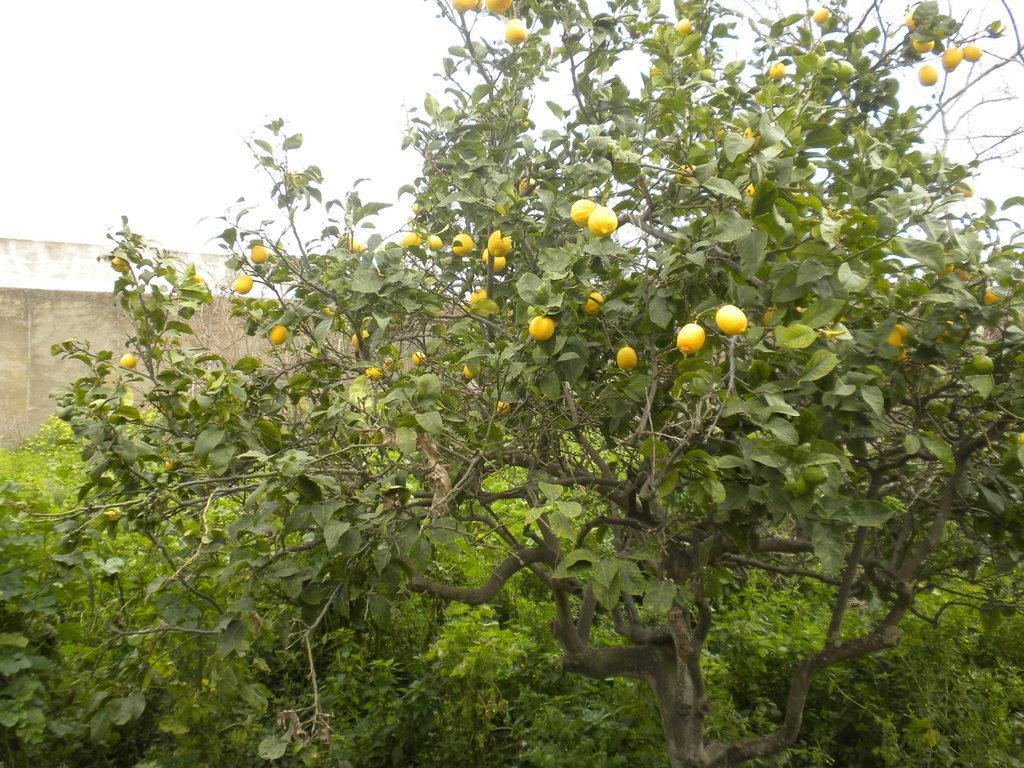Can you describe this image briefly? In this image we can see a tree with fruits and few trees, a wall and a sky in the background. 